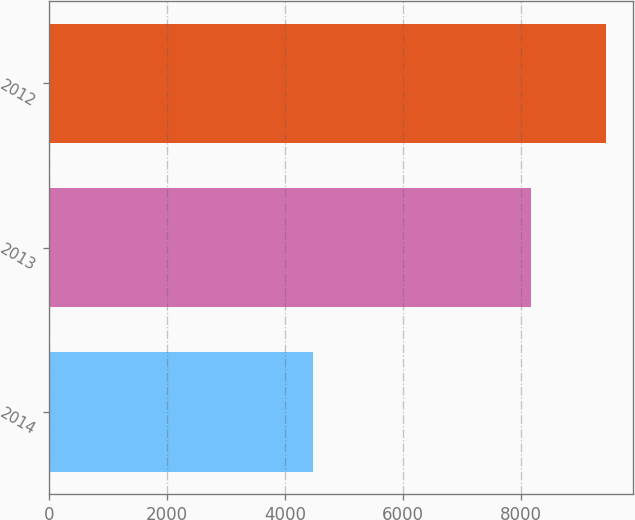Convert chart to OTSL. <chart><loc_0><loc_0><loc_500><loc_500><bar_chart><fcel>2014<fcel>2013<fcel>2012<nl><fcel>4480<fcel>8178<fcel>9441<nl></chart> 